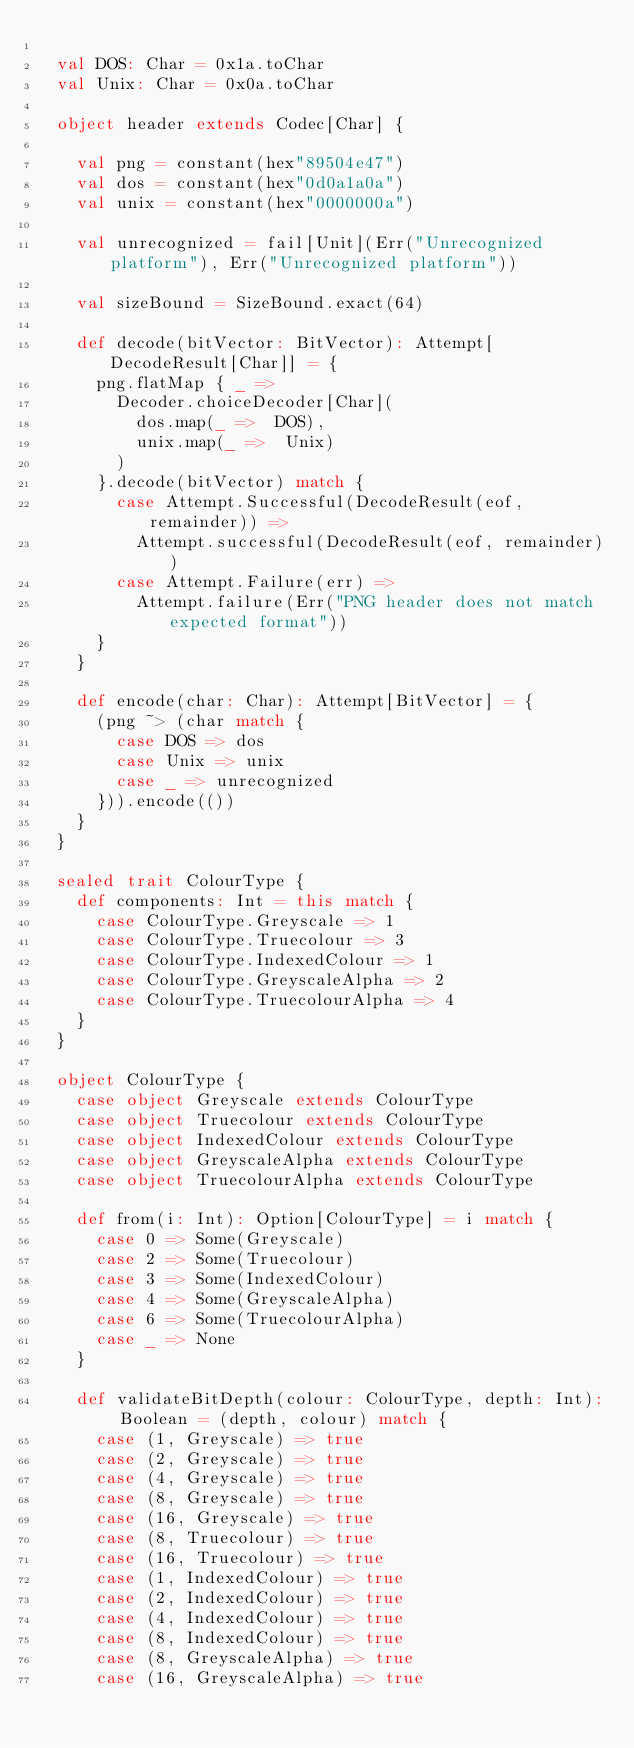Convert code to text. <code><loc_0><loc_0><loc_500><loc_500><_Scala_>
  val DOS: Char = 0x1a.toChar
  val Unix: Char = 0x0a.toChar

  object header extends Codec[Char] {

    val png = constant(hex"89504e47")
    val dos = constant(hex"0d0a1a0a")
    val unix = constant(hex"0000000a")

    val unrecognized = fail[Unit](Err("Unrecognized platform"), Err("Unrecognized platform"))

    val sizeBound = SizeBound.exact(64)

    def decode(bitVector: BitVector): Attempt[DecodeResult[Char]] = {
      png.flatMap { _ =>
        Decoder.choiceDecoder[Char](
          dos.map(_ =>  DOS),
          unix.map(_ =>  Unix)
        )
      }.decode(bitVector) match {
        case Attempt.Successful(DecodeResult(eof, remainder)) =>
          Attempt.successful(DecodeResult(eof, remainder))
        case Attempt.Failure(err) =>
          Attempt.failure(Err("PNG header does not match expected format"))
      }
    }

    def encode(char: Char): Attempt[BitVector] = {
      (png ~> (char match {
        case DOS => dos
        case Unix => unix
        case _ => unrecognized
      })).encode(())
    }
  }

  sealed trait ColourType {
    def components: Int = this match {
      case ColourType.Greyscale => 1
      case ColourType.Truecolour => 3
      case ColourType.IndexedColour => 1
      case ColourType.GreyscaleAlpha => 2
      case ColourType.TruecolourAlpha => 4  
    }
  }

  object ColourType {
    case object Greyscale extends ColourType
    case object Truecolour extends ColourType
    case object IndexedColour extends ColourType
    case object GreyscaleAlpha extends ColourType
    case object TruecolourAlpha extends ColourType

    def from(i: Int): Option[ColourType] = i match {
      case 0 => Some(Greyscale)
      case 2 => Some(Truecolour)
      case 3 => Some(IndexedColour)
      case 4 => Some(GreyscaleAlpha)
      case 6 => Some(TruecolourAlpha)
      case _ => None  
    }

    def validateBitDepth(colour: ColourType, depth: Int): Boolean = (depth, colour) match {
      case (1, Greyscale) => true
      case (2, Greyscale) => true
      case (4, Greyscale) => true
      case (8, Greyscale) => true
      case (16, Greyscale) => true
      case (8, Truecolour) => true
      case (16, Truecolour) => true
      case (1, IndexedColour) => true
      case (2, IndexedColour) => true
      case (4, IndexedColour) => true
      case (8, IndexedColour) => true
      case (8, GreyscaleAlpha) => true
      case (16, GreyscaleAlpha) => true</code> 